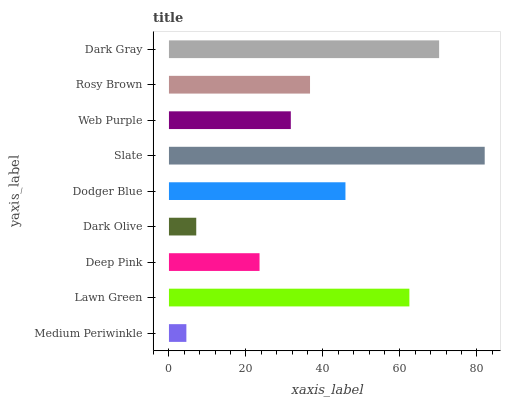Is Medium Periwinkle the minimum?
Answer yes or no. Yes. Is Slate the maximum?
Answer yes or no. Yes. Is Lawn Green the minimum?
Answer yes or no. No. Is Lawn Green the maximum?
Answer yes or no. No. Is Lawn Green greater than Medium Periwinkle?
Answer yes or no. Yes. Is Medium Periwinkle less than Lawn Green?
Answer yes or no. Yes. Is Medium Periwinkle greater than Lawn Green?
Answer yes or no. No. Is Lawn Green less than Medium Periwinkle?
Answer yes or no. No. Is Rosy Brown the high median?
Answer yes or no. Yes. Is Rosy Brown the low median?
Answer yes or no. Yes. Is Web Purple the high median?
Answer yes or no. No. Is Lawn Green the low median?
Answer yes or no. No. 